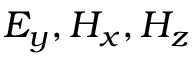Convert formula to latex. <formula><loc_0><loc_0><loc_500><loc_500>E _ { y } , H _ { x } , H _ { z }</formula> 